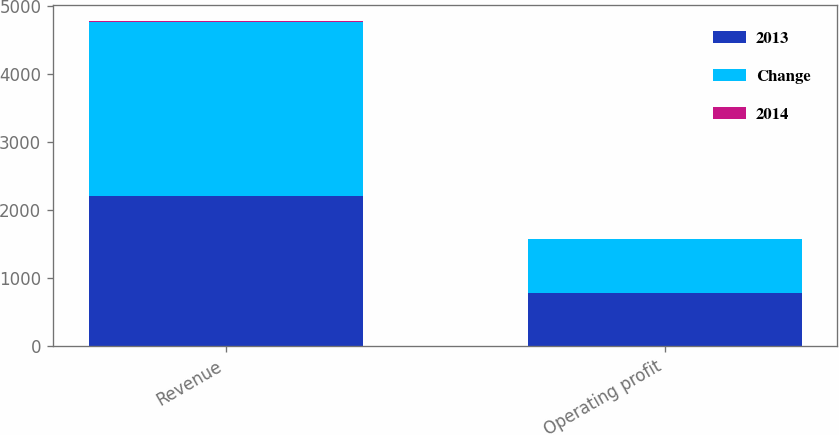<chart> <loc_0><loc_0><loc_500><loc_500><stacked_bar_chart><ecel><fcel>Revenue<fcel>Operating profit<nl><fcel>2013<fcel>2201<fcel>777<nl><fcel>Change<fcel>2561<fcel>788<nl><fcel>2014<fcel>14<fcel>1<nl></chart> 